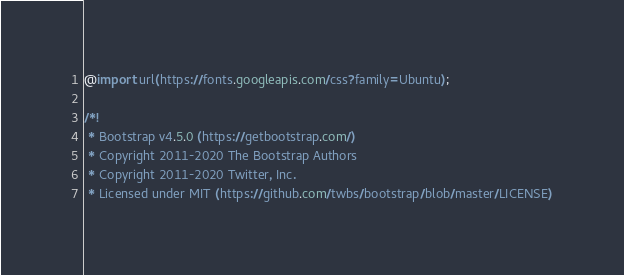Convert code to text. <code><loc_0><loc_0><loc_500><loc_500><_CSS_>@import url(https://fonts.googleapis.com/css?family=Ubuntu);

/*!
 * Bootstrap v4.5.0 (https://getbootstrap.com/)
 * Copyright 2011-2020 The Bootstrap Authors
 * Copyright 2011-2020 Twitter, Inc.
 * Licensed under MIT (https://github.com/twbs/bootstrap/blob/master/LICENSE)</code> 